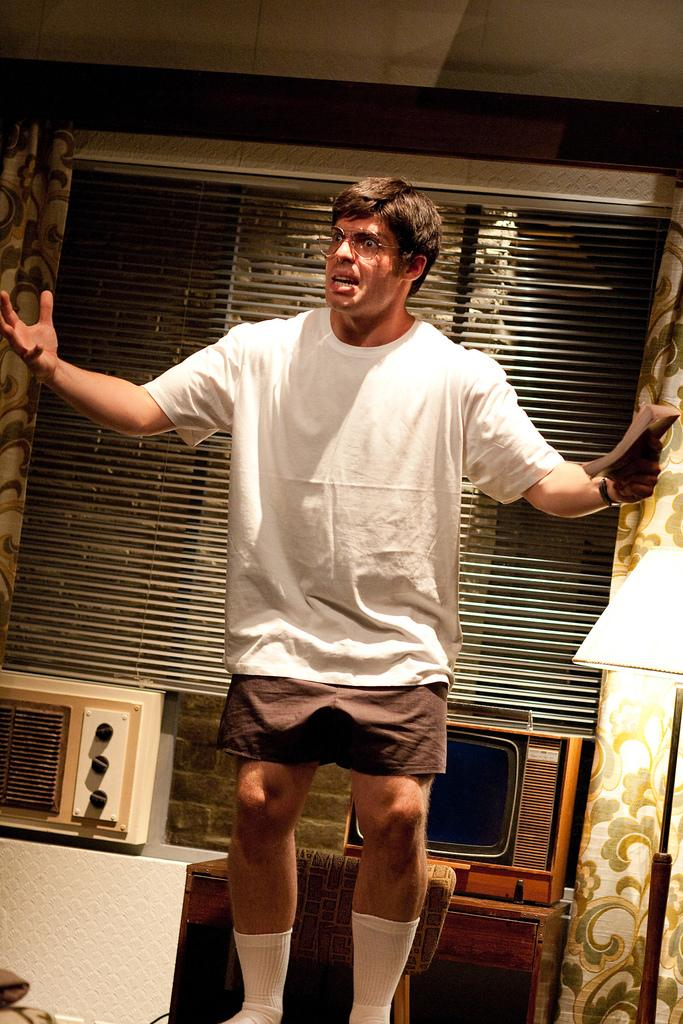What is the man in the image doing? The man is talking in the image. What color is the t-shirt the man is wearing? The man is wearing a white t-shirt. What color are the shorts the man is wearing? The man is wearing brown shorts. What color are the socks the man is wearing? The man is wearing white socks. What is behind the man in the image? There is a glass window and a window shutter behind the man. How many rings does the man have on his fingers in the image? There is no information about rings on the man's fingers in the image. 